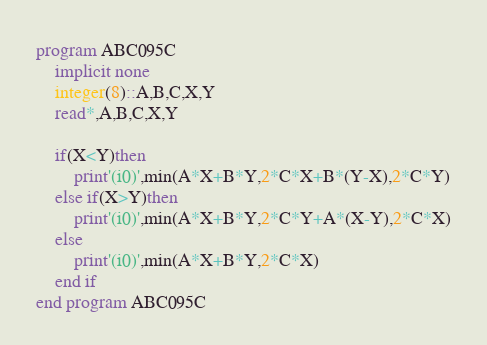Convert code to text. <code><loc_0><loc_0><loc_500><loc_500><_FORTRAN_>program ABC095C
    implicit none
    integer(8)::A,B,C,X,Y
    read*,A,B,C,X,Y

    if(X<Y)then
        print'(i0)',min(A*X+B*Y,2*C*X+B*(Y-X),2*C*Y)
    else if(X>Y)then
        print'(i0)',min(A*X+B*Y,2*C*Y+A*(X-Y),2*C*X)
    else
        print'(i0)',min(A*X+B*Y,2*C*X)
    end if
end program ABC095C</code> 